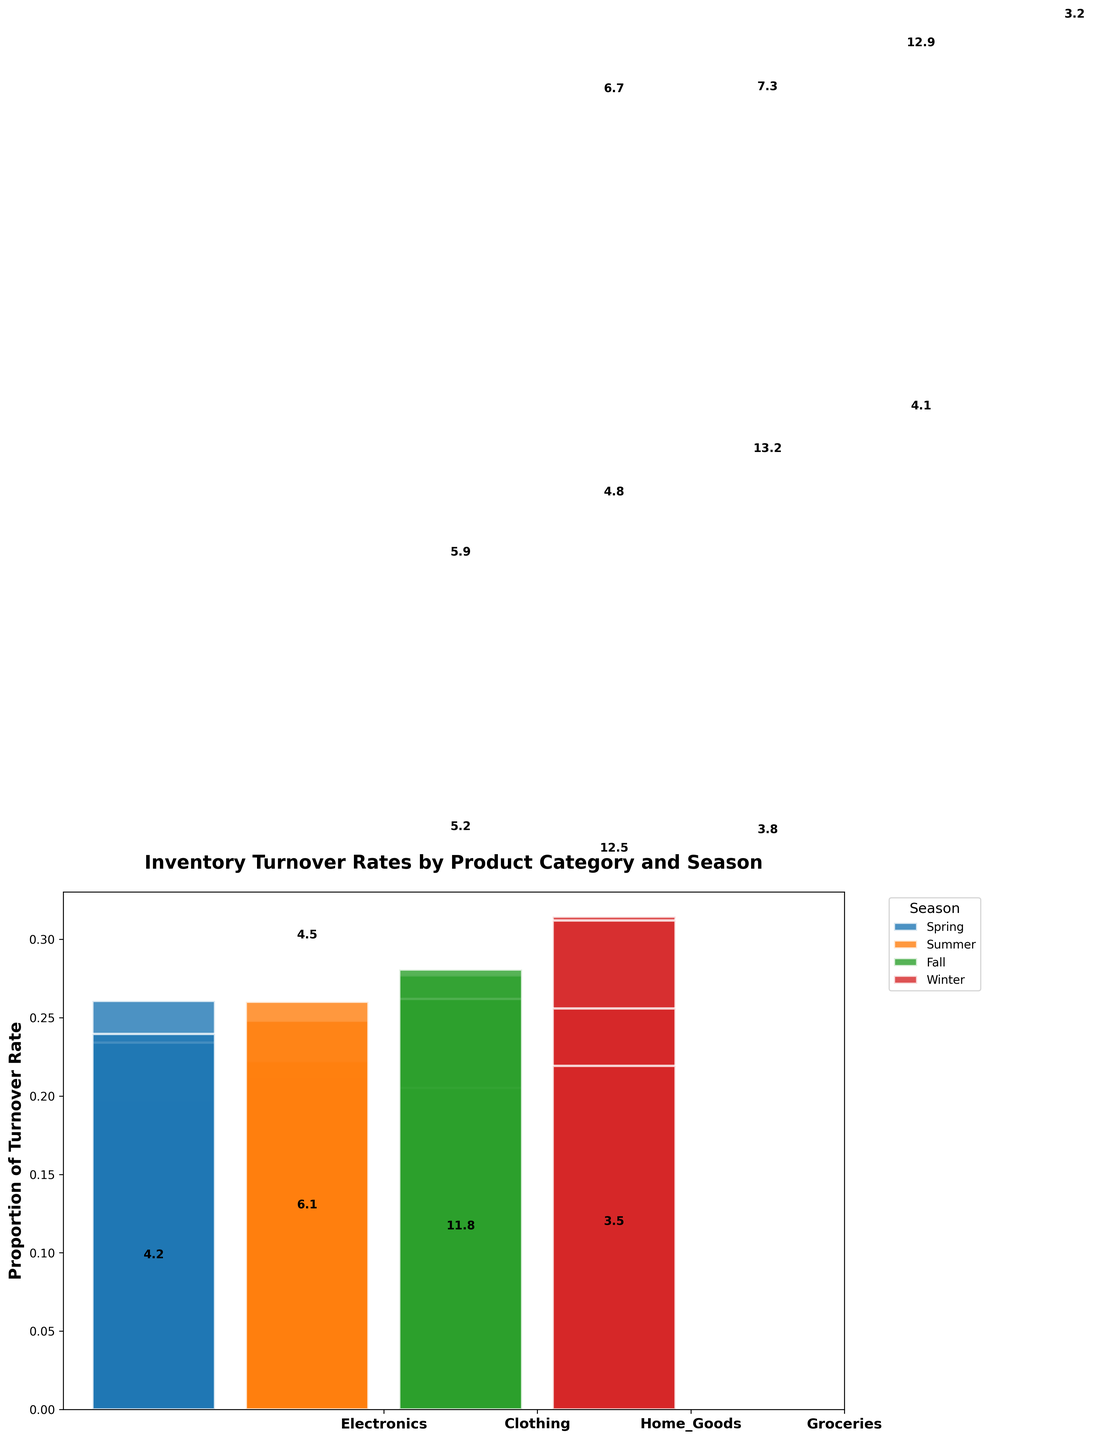What is the title of the plot? The title is typically located at the top of the figure and usually is in a larger and bold font to stand out.
Answer: Inventory Turnover Rates by Product Category and Season Which product category has the highest inventory turnover rate in winter? To find this, look at the winter bar for each product category and check which one reaches the highest proportion.
Answer: Electronics What's the range of turnover rates for 'Clothing' throughout the seasons? Identify the highest and lowest turnover rates for 'Clothing' across all seasons and compute the difference. The rates are 4.5, 5.9, 4.2, and 6.7. To find the range, subtract the lowest from the highest: 6.7 - 4.2 = 2.5.
Answer: 2.5 How does the inventory turnover rate for 'Electronics' vary between spring and fall? Check the heights of the bars for 'Electronics' in spring and fall to determine the rates. Spring is 5.2 and Fall is 6.1, yielding a difference of 6.1 - 5.2 = 0.9.
Answer: 0.9 Which season has the lowest inventory turnover rate for 'Home Goods'? Examine the heights of the bars for each season in the 'Home Goods' category, and identify the shortest bar, which corresponds to the lowest rate.
Answer: Winter Do 'Groceries' have a higher turnover rate in summer compared to spring? Look at the heights of the bars for 'Groceries' in spring and summer and compare them. Spring is 12.5 and Summer is 13.2.
Answer: Yes Calculate the total turnover rate for 'Clothing' across all seasons. Add the turnover rates for 'Clothing' in all four seasons: 4.5 + 5.9 + 4.2 + 6.7 = 21.3.
Answer: 21.3 Which product category has the most consistent turnover rate across all seasons? Consistency means the rates don't fluctuate wildly. Compare the ranges of turnover rates for each category: ‘Electronics’ (7.3 - 4.8 = 2.5), ‘Clothing’ (6.7 - 4.2 = 2.5), ‘Home Goods’ (4.1 - 3.2 = 0.9), and ‘Groceries’ (13.2 - 11.8 = 1.4). The smallest range indicates the most consistency.
Answer: Home Goods What is the average turnover rate for 'Electronics'? Calculate the mean of the turnover rates for 'Electronics' by summing the rates and dividing by the number of seasons: (5.2 + 4.8 + 6.1 + 7.3) / 4 = 5.85.
Answer: 5.85 Identify the season with the highest overall inventory turnover rate. For this, consider each category's rate in each season and determine which season consistently has the higher values. Summarize the turnover rates for each season and find the highest sum: Spring (5.2+4.5+3.8+12.5=26.0), Summer (4.8+5.9+4.1+13.2=28.0), Fall (6.1+4.2+3.5+11.8=25.6), Winter (7.3+6.7+3.2+12.9=30.1).
Answer: Winter 